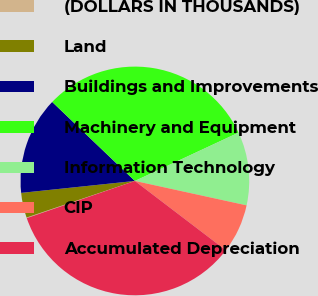<chart> <loc_0><loc_0><loc_500><loc_500><pie_chart><fcel>(DOLLARS IN THOUSANDS)<fcel>Land<fcel>Buildings and Improvements<fcel>Machinery and Equipment<fcel>Information Technology<fcel>CIP<fcel>Accumulated Depreciation<nl><fcel>0.09%<fcel>3.52%<fcel>13.8%<fcel>30.92%<fcel>10.37%<fcel>6.94%<fcel>34.36%<nl></chart> 